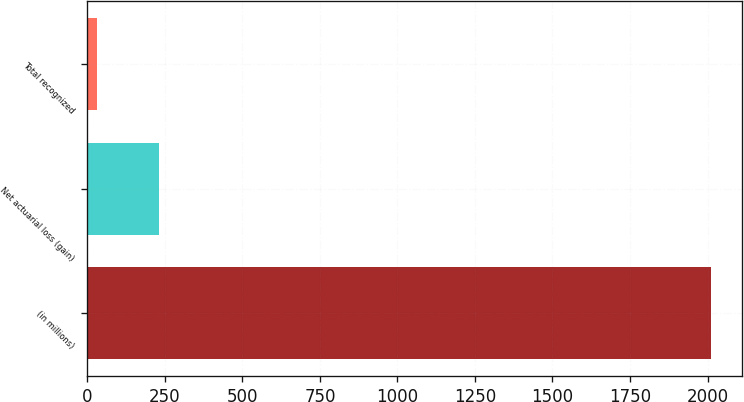Convert chart to OTSL. <chart><loc_0><loc_0><loc_500><loc_500><bar_chart><fcel>(in millions)<fcel>Net actuarial loss (gain)<fcel>Total recognized<nl><fcel>2010<fcel>229.8<fcel>32<nl></chart> 